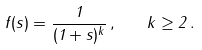<formula> <loc_0><loc_0><loc_500><loc_500>f ( s ) = \frac { 1 } { ( 1 + s ) ^ { k } } \, , \quad k \geq 2 \, .</formula> 